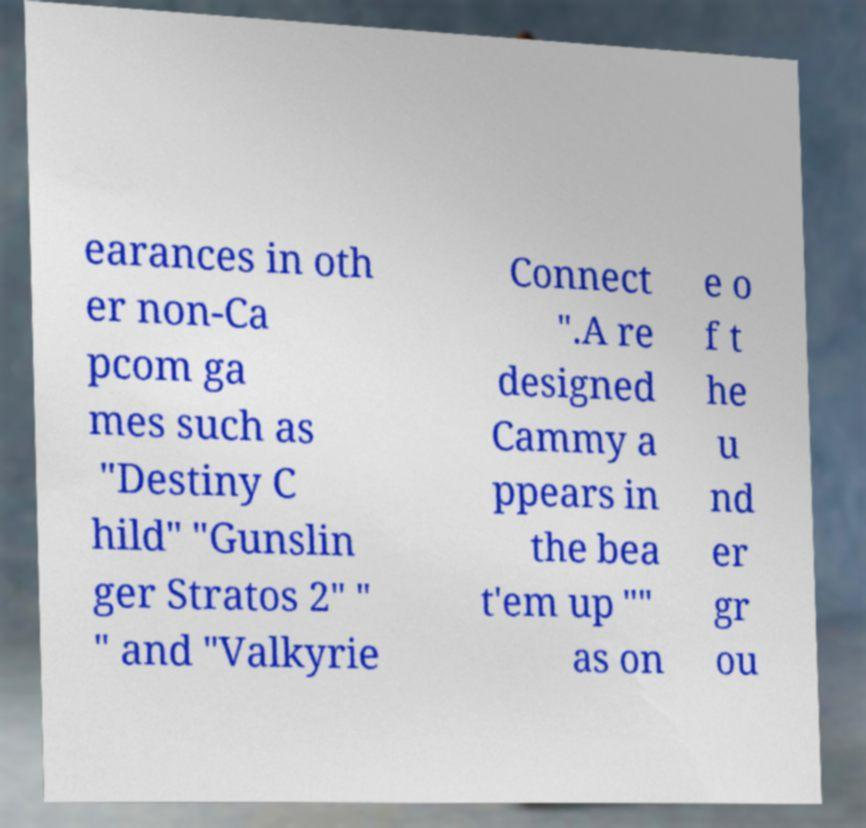Please identify and transcribe the text found in this image. earances in oth er non-Ca pcom ga mes such as "Destiny C hild" "Gunslin ger Stratos 2" " " and "Valkyrie Connect ".A re designed Cammy a ppears in the bea t'em up "" as on e o f t he u nd er gr ou 